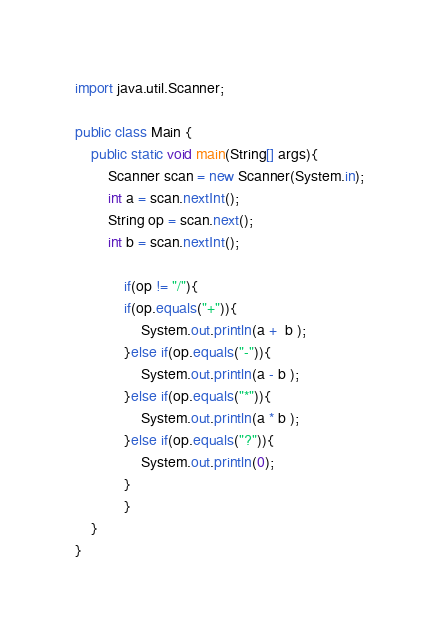<code> <loc_0><loc_0><loc_500><loc_500><_Java_>import java.util.Scanner;

public class Main {
	public static void main(String[] args){
		Scanner scan = new Scanner(System.in);
		int a = scan.nextInt();
		String op = scan.next();
		int b = scan.nextInt();
			
			if(op != "/"){
			if(op.equals("+")){
				System.out.println(a +  b );
			}else if(op.equals("-")){
				System.out.println(a - b );
			}else if(op.equals("*")){
				System.out.println(a * b );
			}else if(op.equals("?")){
				System.out.println(0);			
			}
			}
	}
}</code> 